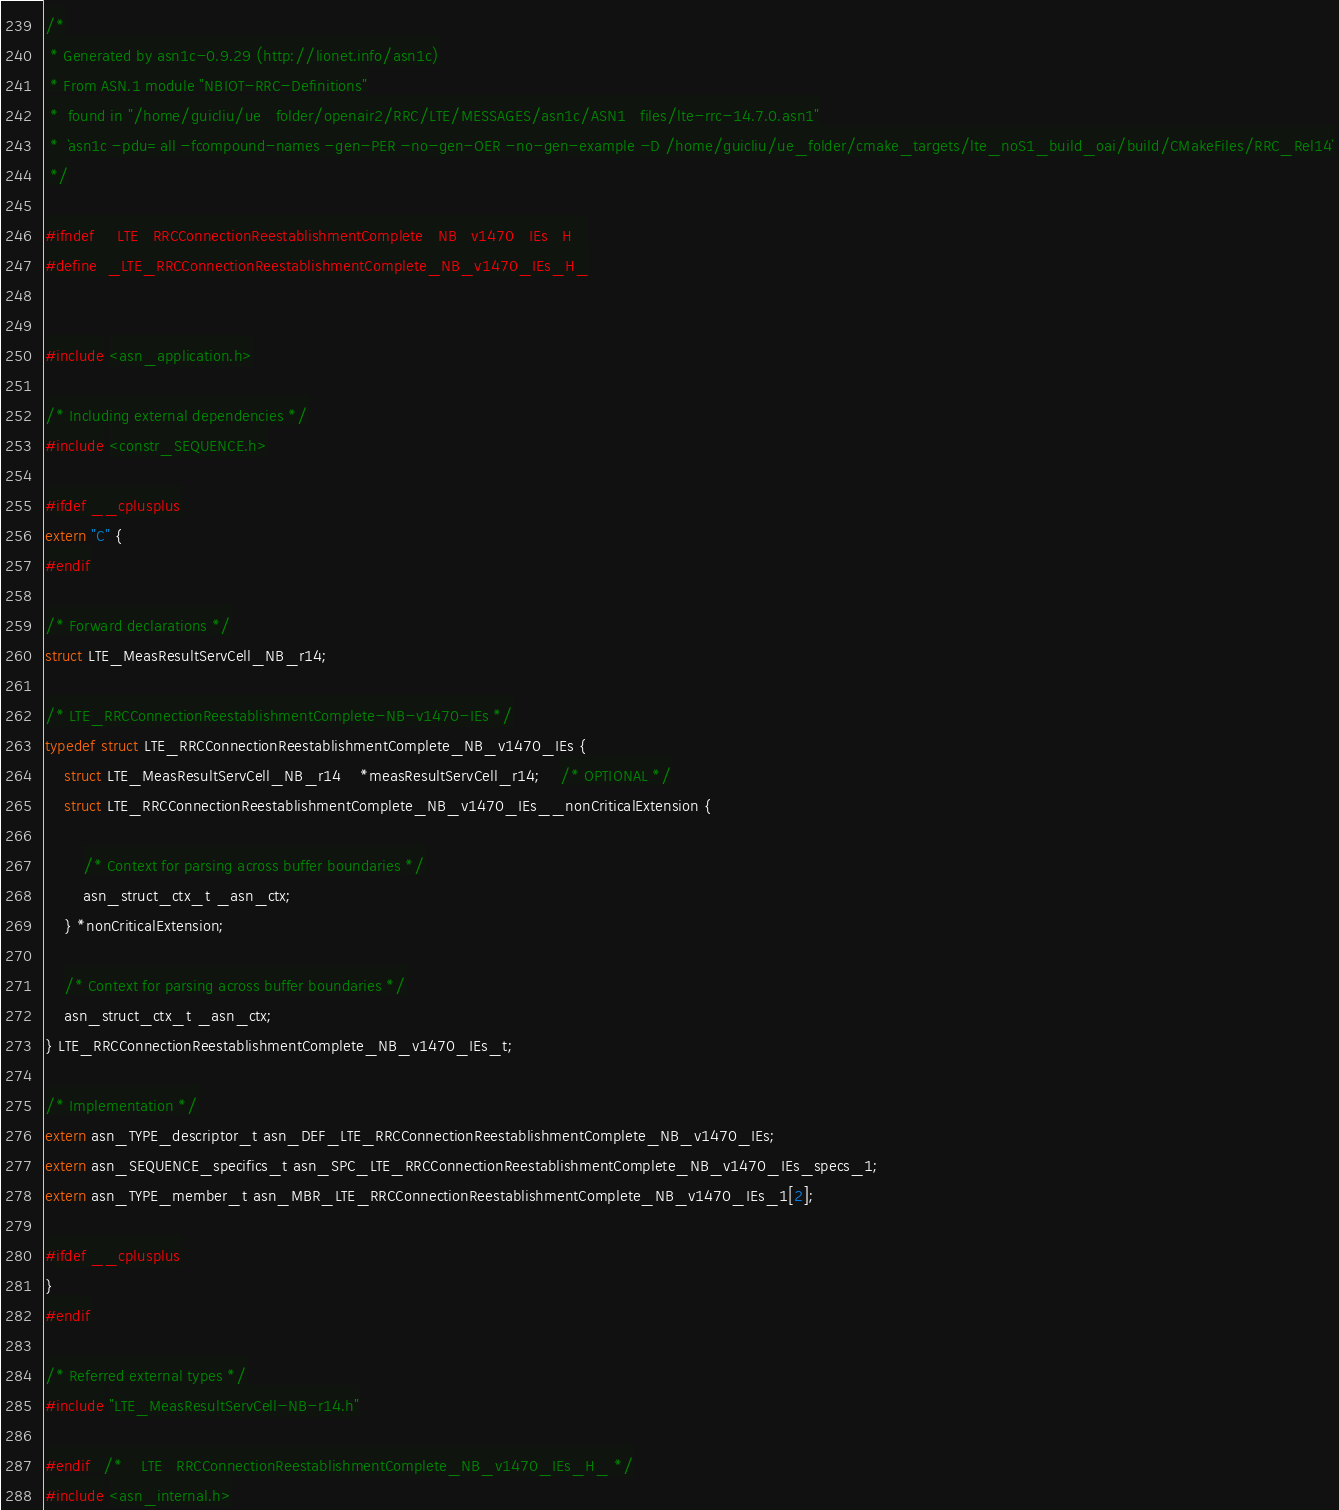Convert code to text. <code><loc_0><loc_0><loc_500><loc_500><_C_>/*
 * Generated by asn1c-0.9.29 (http://lionet.info/asn1c)
 * From ASN.1 module "NBIOT-RRC-Definitions"
 * 	found in "/home/guicliu/ue_folder/openair2/RRC/LTE/MESSAGES/asn1c/ASN1_files/lte-rrc-14.7.0.asn1"
 * 	`asn1c -pdu=all -fcompound-names -gen-PER -no-gen-OER -no-gen-example -D /home/guicliu/ue_folder/cmake_targets/lte_noS1_build_oai/build/CMakeFiles/RRC_Rel14`
 */

#ifndef	_LTE_RRCConnectionReestablishmentComplete_NB_v1470_IEs_H_
#define	_LTE_RRCConnectionReestablishmentComplete_NB_v1470_IEs_H_


#include <asn_application.h>

/* Including external dependencies */
#include <constr_SEQUENCE.h>

#ifdef __cplusplus
extern "C" {
#endif

/* Forward declarations */
struct LTE_MeasResultServCell_NB_r14;

/* LTE_RRCConnectionReestablishmentComplete-NB-v1470-IEs */
typedef struct LTE_RRCConnectionReestablishmentComplete_NB_v1470_IEs {
	struct LTE_MeasResultServCell_NB_r14	*measResultServCell_r14;	/* OPTIONAL */
	struct LTE_RRCConnectionReestablishmentComplete_NB_v1470_IEs__nonCriticalExtension {
		
		/* Context for parsing across buffer boundaries */
		asn_struct_ctx_t _asn_ctx;
	} *nonCriticalExtension;
	
	/* Context for parsing across buffer boundaries */
	asn_struct_ctx_t _asn_ctx;
} LTE_RRCConnectionReestablishmentComplete_NB_v1470_IEs_t;

/* Implementation */
extern asn_TYPE_descriptor_t asn_DEF_LTE_RRCConnectionReestablishmentComplete_NB_v1470_IEs;
extern asn_SEQUENCE_specifics_t asn_SPC_LTE_RRCConnectionReestablishmentComplete_NB_v1470_IEs_specs_1;
extern asn_TYPE_member_t asn_MBR_LTE_RRCConnectionReestablishmentComplete_NB_v1470_IEs_1[2];

#ifdef __cplusplus
}
#endif

/* Referred external types */
#include "LTE_MeasResultServCell-NB-r14.h"

#endif	/* _LTE_RRCConnectionReestablishmentComplete_NB_v1470_IEs_H_ */
#include <asn_internal.h>
</code> 